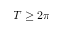<formula> <loc_0><loc_0><loc_500><loc_500>T \geq 2 \pi</formula> 